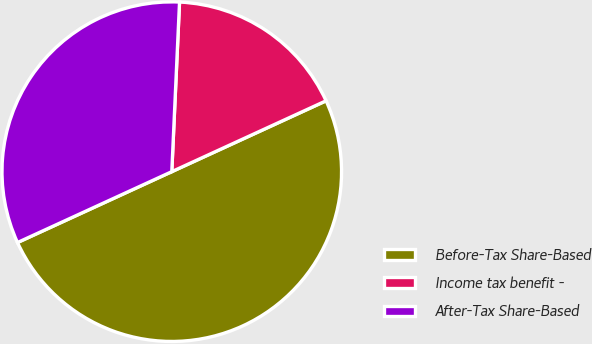<chart> <loc_0><loc_0><loc_500><loc_500><pie_chart><fcel>Before-Tax Share-Based<fcel>Income tax benefit -<fcel>After-Tax Share-Based<nl><fcel>50.0%<fcel>17.42%<fcel>32.58%<nl></chart> 